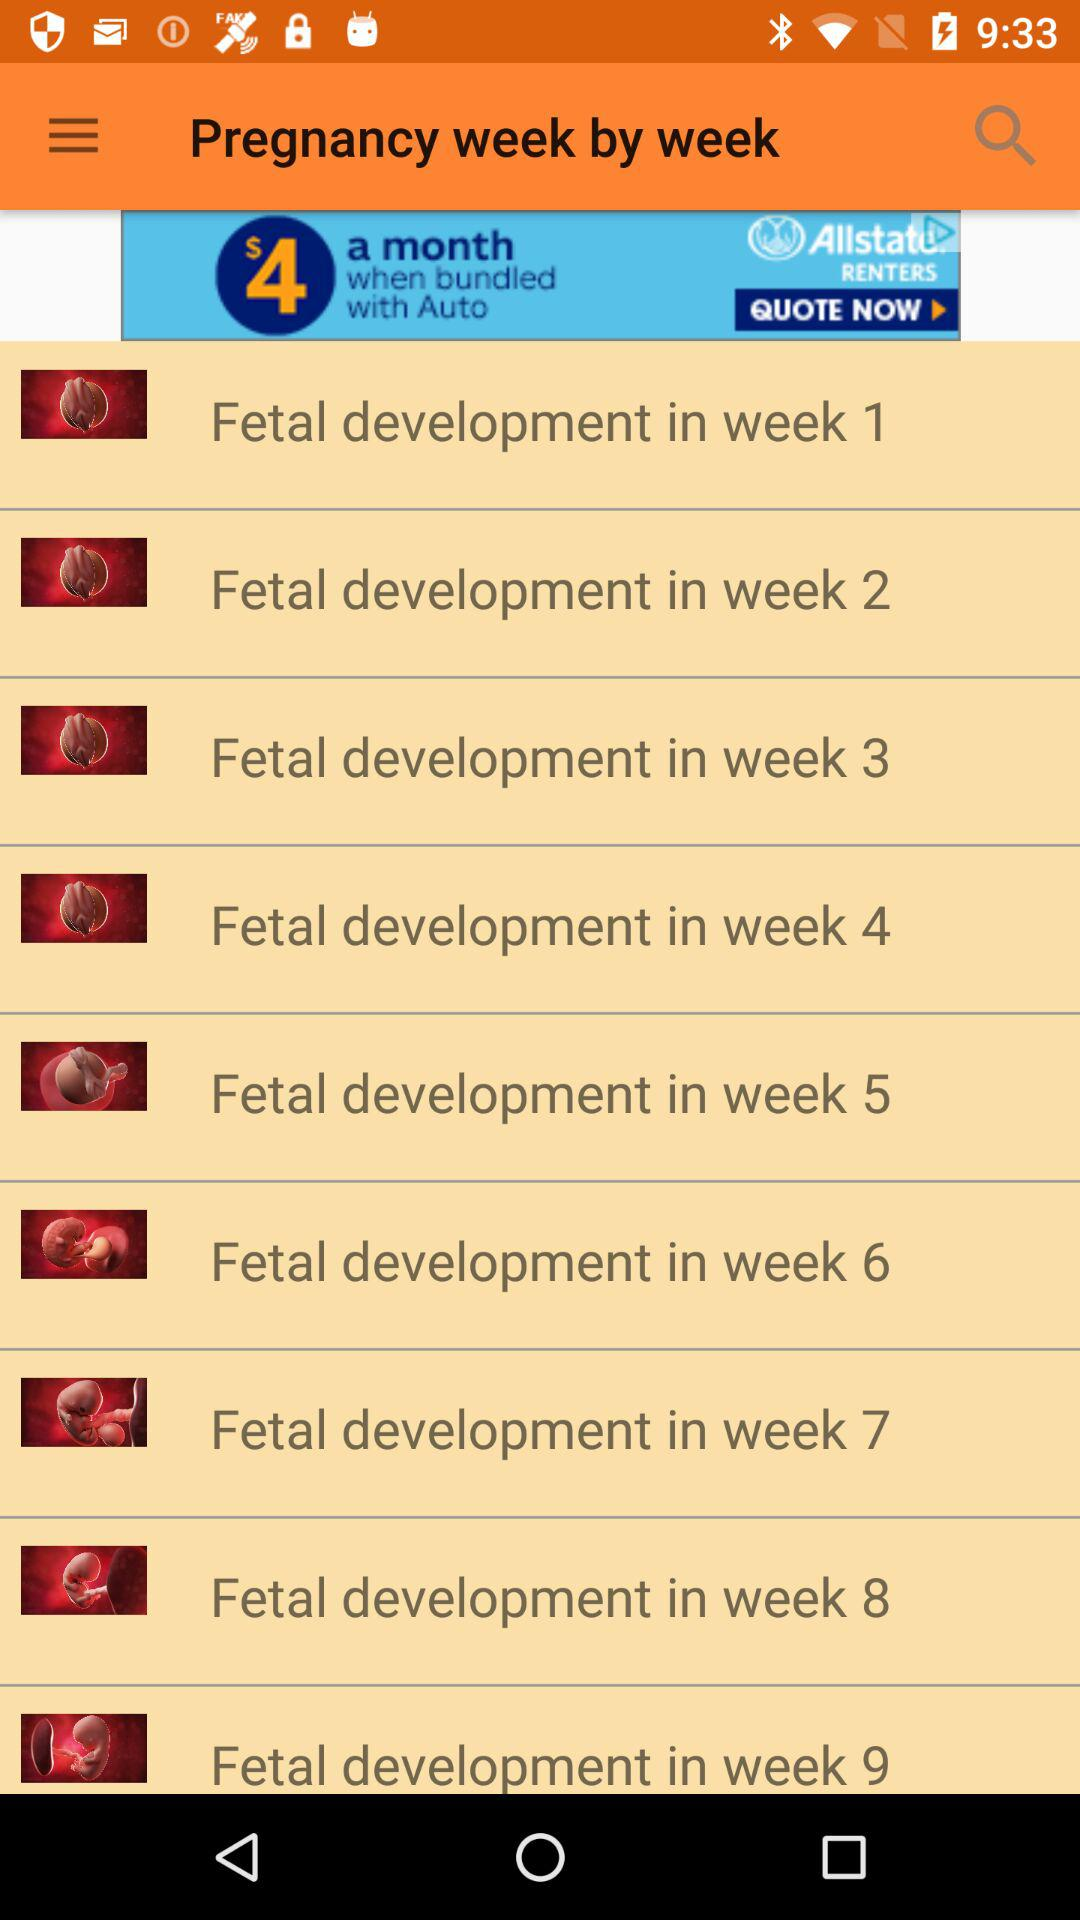How many weeks are there in the pregnancy timeline?
Answer the question using a single word or phrase. 9 